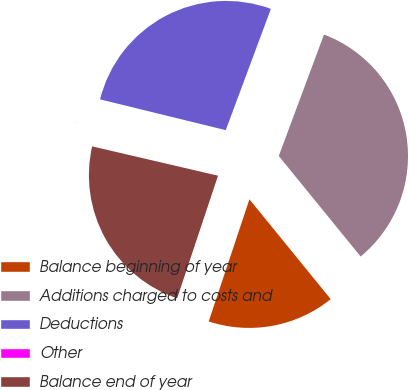Convert chart to OTSL. <chart><loc_0><loc_0><loc_500><loc_500><pie_chart><fcel>Balance beginning of year<fcel>Additions charged to costs and<fcel>Deductions<fcel>Other<fcel>Balance end of year<nl><fcel>16.0%<fcel>33.45%<fcel>26.85%<fcel>0.18%<fcel>23.52%<nl></chart> 